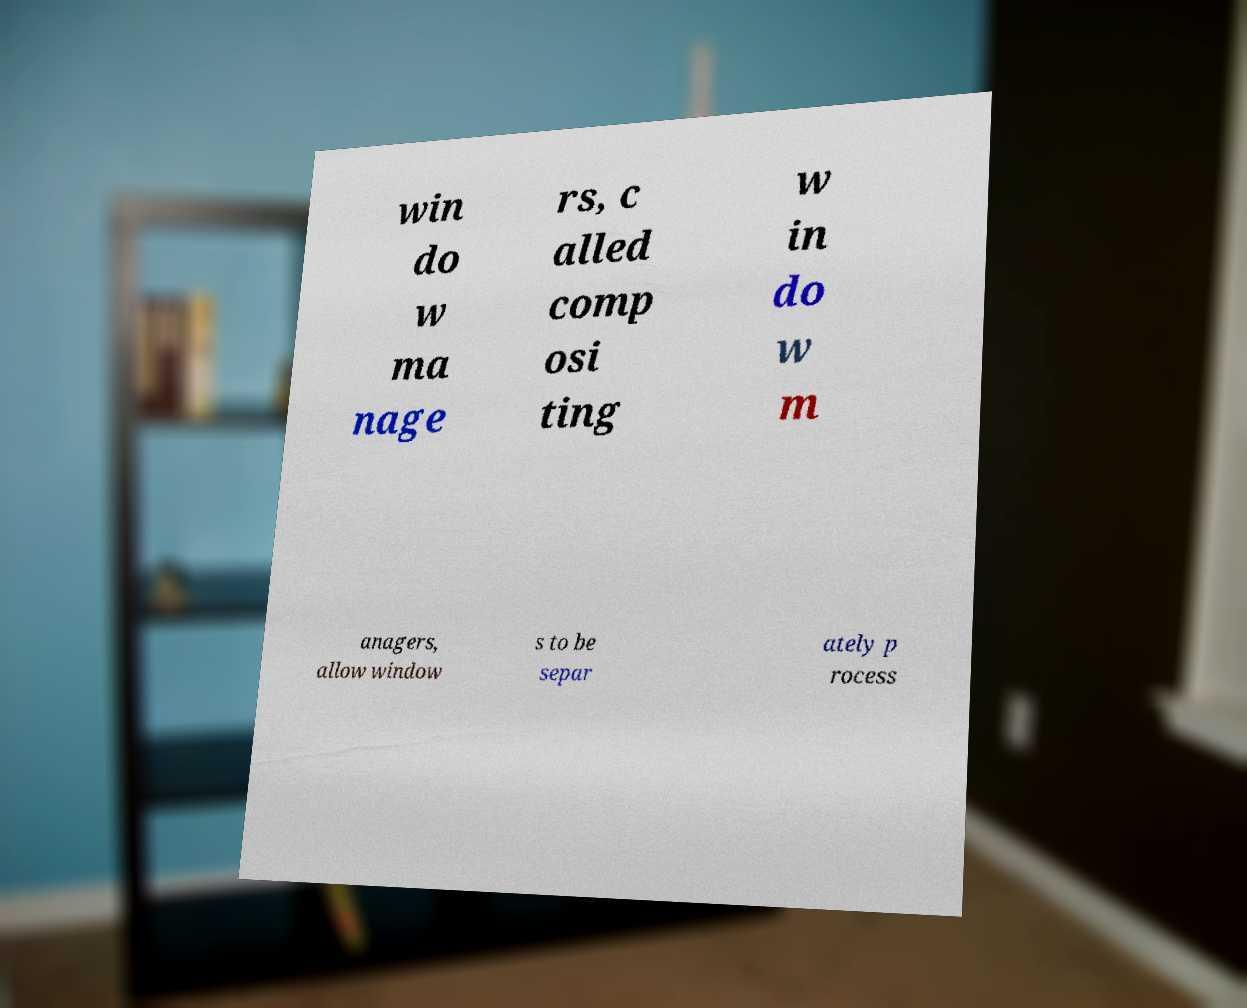Please identify and transcribe the text found in this image. win do w ma nage rs, c alled comp osi ting w in do w m anagers, allow window s to be separ ately p rocess 